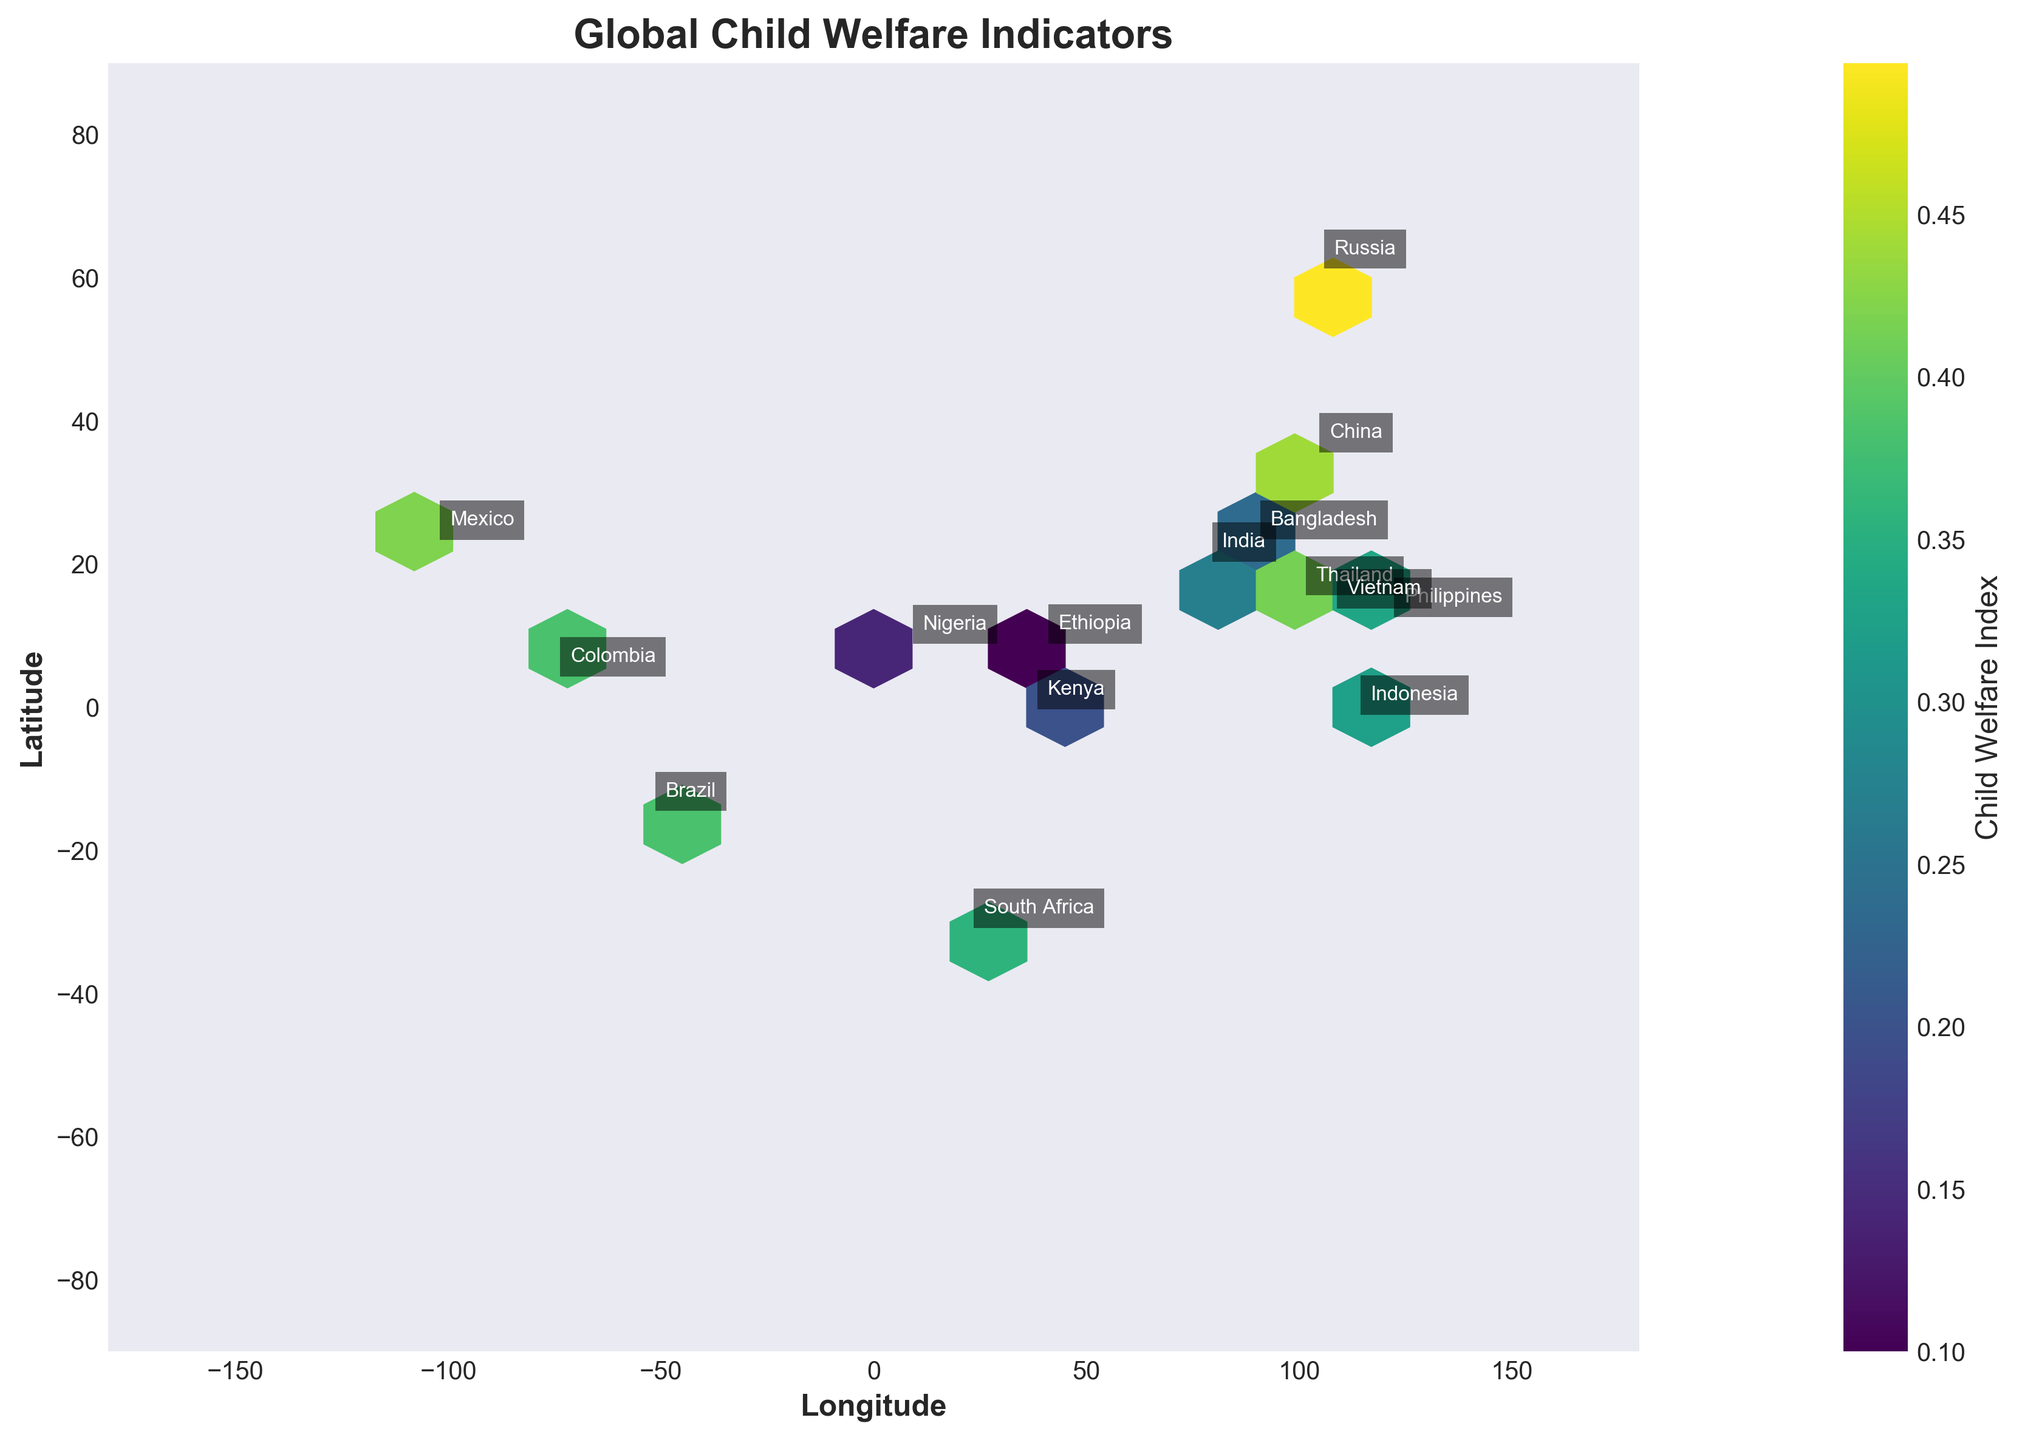What is the title of the plot? The title of the plot is displayed at the top of the figure in bold font as 'Global Child Welfare Indicators'.
Answer: Global Child Welfare Indicators How many countries are labeled on the plot? By counting the annotations placed on the plot at the latitude and longitude coordinates of each country, we can see there are 15 countries labeled.
Answer: 15 What are the axes labels in the plot? The x-axis is labeled as 'Longitude' and the y-axis is labeled as 'Latitude', both in bold font.
Answer: Longitude, Latitude Which country has the highest welfare index in the plot? By comparing the positions and associated colors of labeled countries, Russia exhibits the highest welfare index indicated by the brightest color on the hexbin plot.
Answer: Russia Which region (latitude and longitude range) has a high density of countries with significant child welfare index values? To answer this, observe the hexbin plot color intensities and density of hexagons. A high density of significant values is located around the latitudes 10 to 40 and longitudes 60 to 120, corresponding to South Asia and Southeast Asia.
Answer: South Asia and Southeast Asia Which country appears to have the lowest welfare index among those plotted? Analyzing the color shade of labeled countries, Ethiopia shows the darkest shade, indicating the lowest welfare index.
Answer: Ethiopia How does Brazil's child welfare index compare to that of Nigeria? Brazil is associated with a brighter color hexbin point compared to Nigeria, indicating Brazil has a higher welfare index than Nigeria.
Answer: Brazil has a higher welfare index than Nigeria What three factors contribute to the computed welfare index shown in the color of each hexbin? The welfare index is computed as the average of Education Access and Healthcare Availability, subtracting Poverty Level.
Answer: Education Access, Healthcare Availability, Poverty Level Which country in Africa shows the highest welfare index on the plot? By checking the colors and annotations for African countries, South Africa has the brightest color, indicating the highest welfare index among African countries.
Answer: South Africa What is the welfare index calculation for India based on the plot information? Using the formula (Education Access + Healthcare Availability - Poverty Level) / 3: For India (0.65 + 0.58 - 0.42) / 3 = 0.27.
Answer: 0.27 